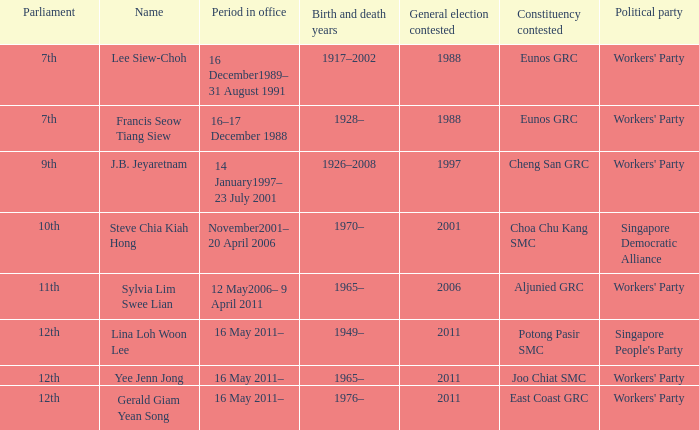What number parliament held it's election in 1997? 9th. 